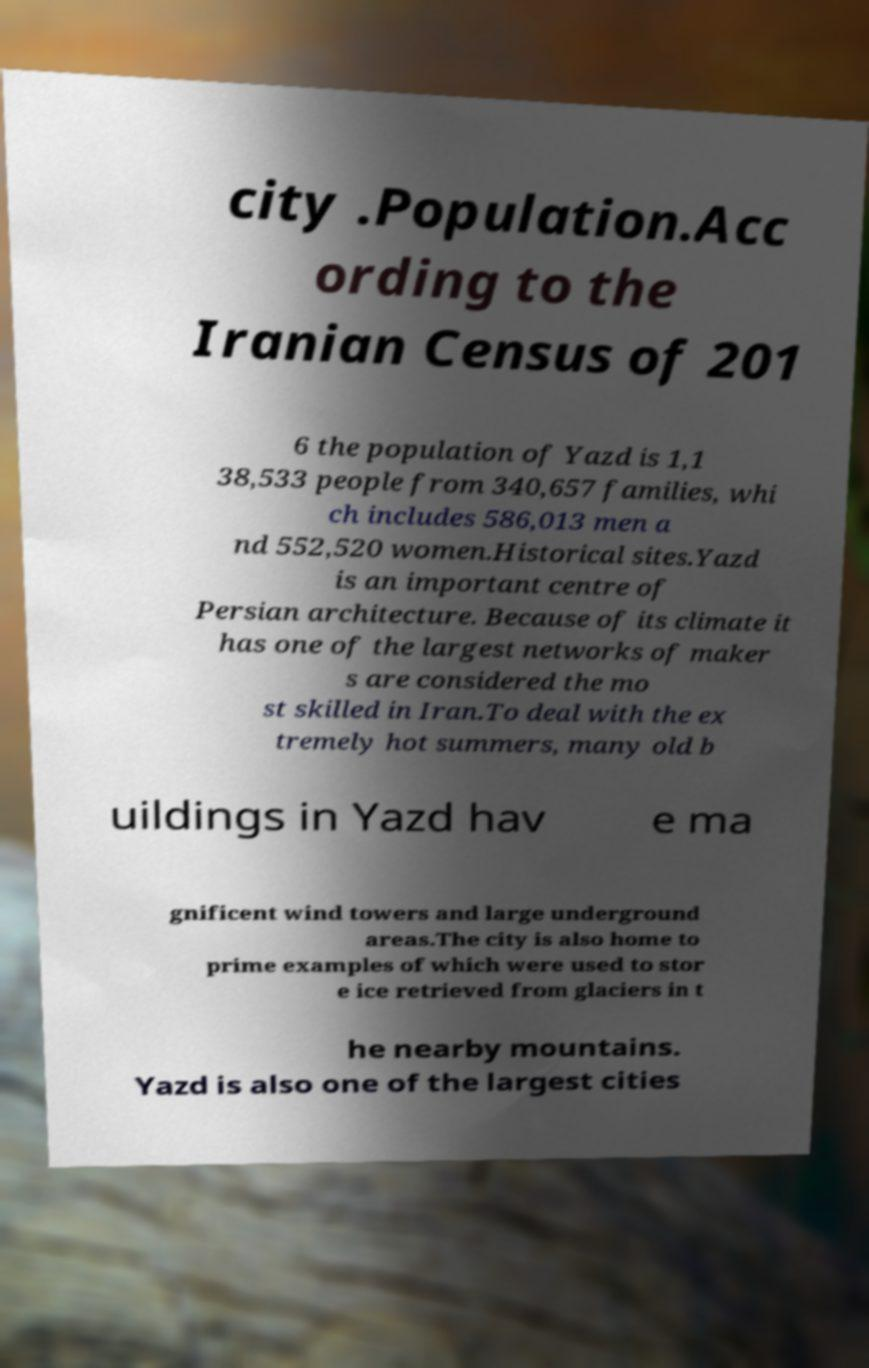Could you extract and type out the text from this image? city .Population.Acc ording to the Iranian Census of 201 6 the population of Yazd is 1,1 38,533 people from 340,657 families, whi ch includes 586,013 men a nd 552,520 women.Historical sites.Yazd is an important centre of Persian architecture. Because of its climate it has one of the largest networks of maker s are considered the mo st skilled in Iran.To deal with the ex tremely hot summers, many old b uildings in Yazd hav e ma gnificent wind towers and large underground areas.The city is also home to prime examples of which were used to stor e ice retrieved from glaciers in t he nearby mountains. Yazd is also one of the largest cities 